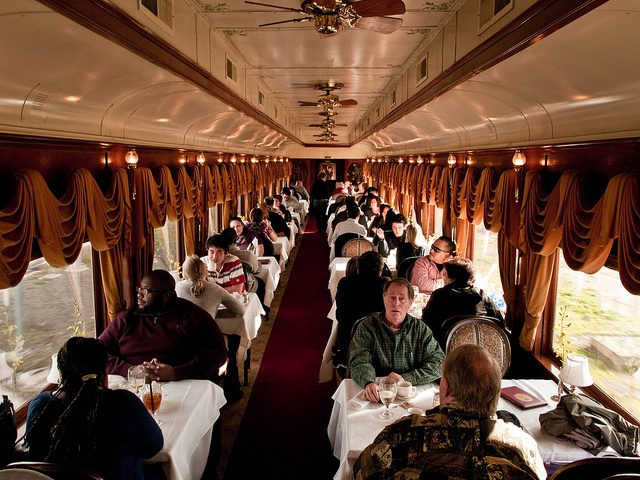Describe the objects in this image and their specific colors. I can see train in brown, gray, maroon, and black tones, people in brown, black, maroon, and white tones, people in brown, black, maroon, and white tones, people in brown, black, maroon, lightgray, and gray tones, and dining table in brown, lightgray, black, darkgray, and tan tones in this image. 